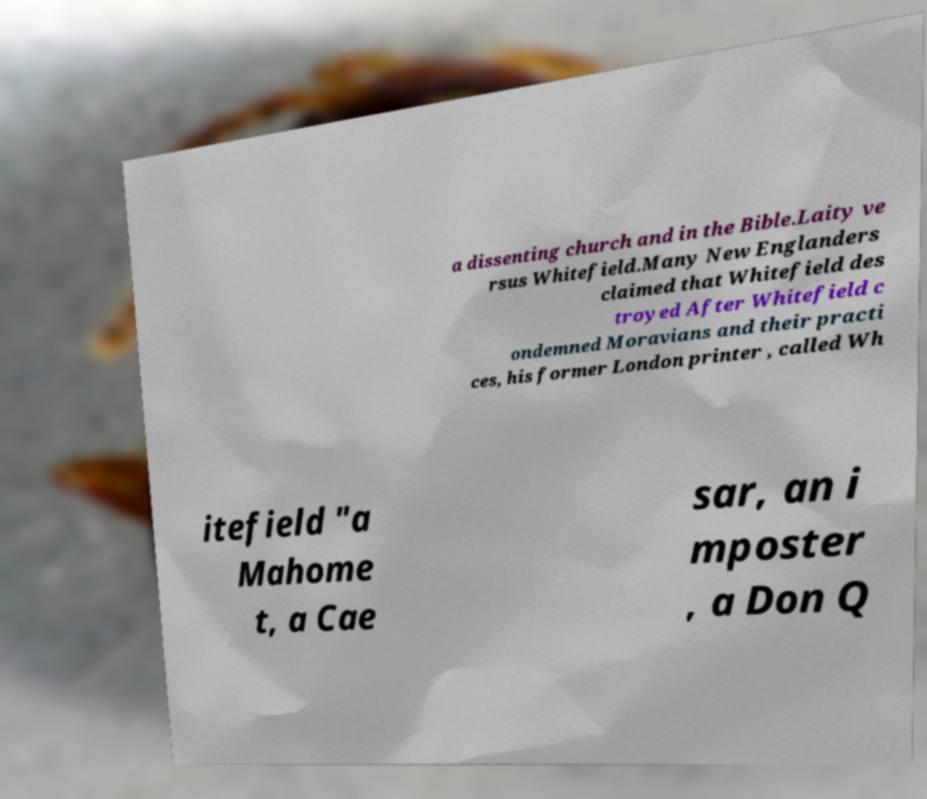Please read and relay the text visible in this image. What does it say? a dissenting church and in the Bible.Laity ve rsus Whitefield.Many New Englanders claimed that Whitefield des troyed After Whitefield c ondemned Moravians and their practi ces, his former London printer , called Wh itefield "a Mahome t, a Cae sar, an i mposter , a Don Q 